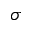<formula> <loc_0><loc_0><loc_500><loc_500>\sigma</formula> 